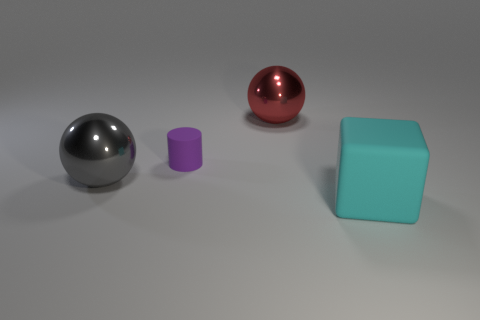Are there any other things that have the same size as the purple thing?
Offer a terse response. No. What number of other things are the same shape as the purple rubber thing?
Give a very brief answer. 0. Does the gray sphere have the same material as the red sphere?
Your response must be concise. Yes. What is the material of the object that is in front of the purple thing and on the left side of the red object?
Ensure brevity in your answer.  Metal. What is the color of the matte object behind the cyan block?
Make the answer very short. Purple. Are there more things that are in front of the tiny rubber cylinder than large spheres?
Keep it short and to the point. No. What number of other objects are there of the same size as the cyan rubber object?
Give a very brief answer. 2. There is a purple matte object; how many metal objects are to the right of it?
Your response must be concise. 1. Are there the same number of large things that are right of the large red object and metallic objects that are to the left of the cyan cube?
Offer a terse response. No. What is the size of the other shiny object that is the same shape as the large red metallic thing?
Make the answer very short. Large. 